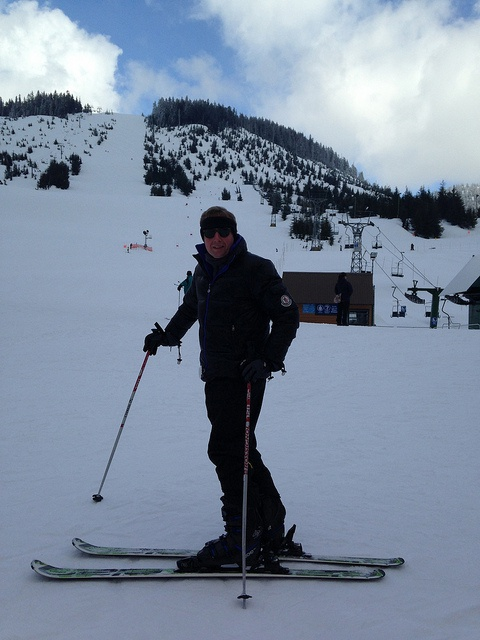Describe the objects in this image and their specific colors. I can see people in lightblue, black, darkgray, and gray tones, skis in lightblue, black, and gray tones, and people in lightblue and black tones in this image. 